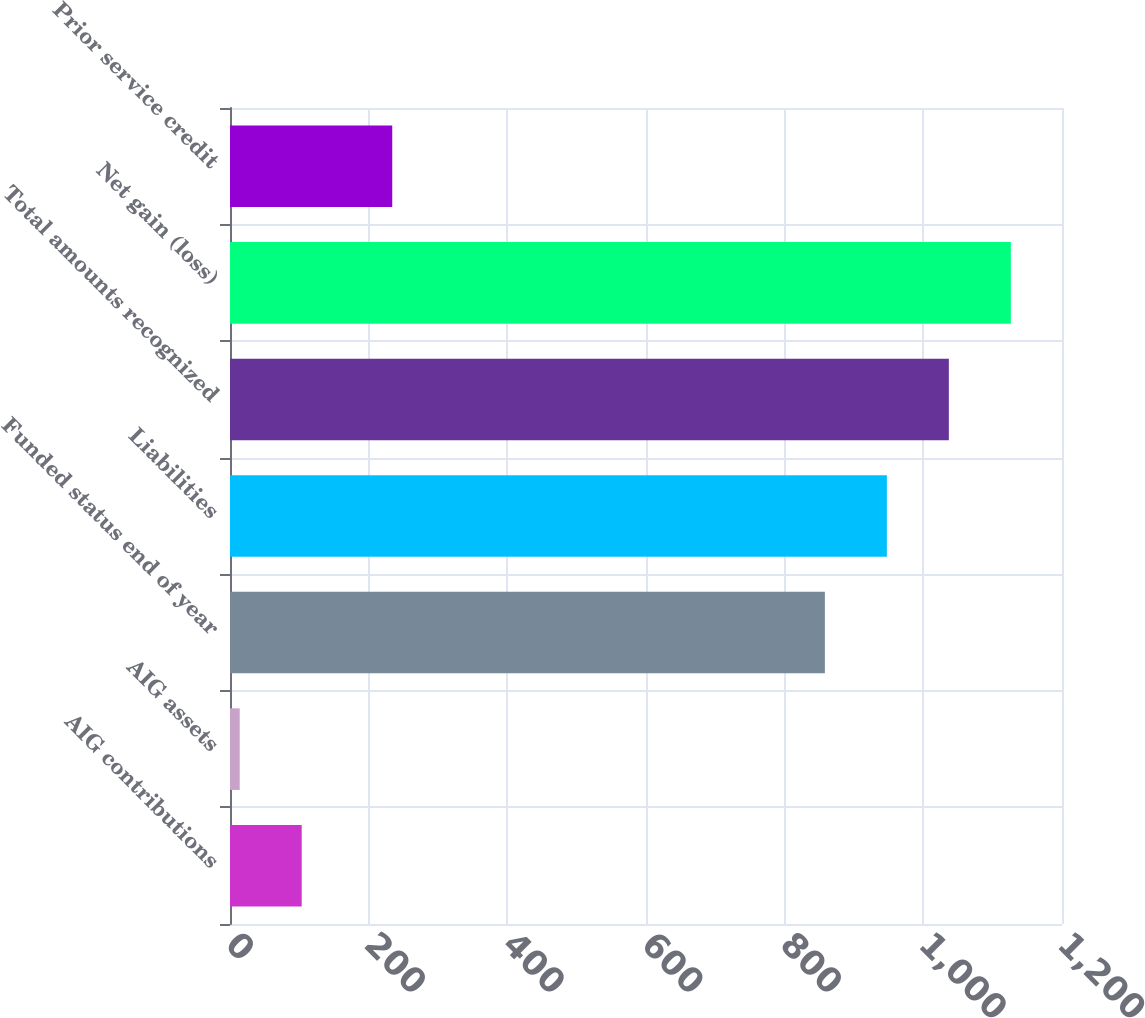<chart> <loc_0><loc_0><loc_500><loc_500><bar_chart><fcel>AIG contributions<fcel>AIG assets<fcel>Funded status end of year<fcel>Liabilities<fcel>Total amounts recognized<fcel>Net gain (loss)<fcel>Prior service credit<nl><fcel>103.4<fcel>14<fcel>858<fcel>947.4<fcel>1036.8<fcel>1126.2<fcel>234<nl></chart> 